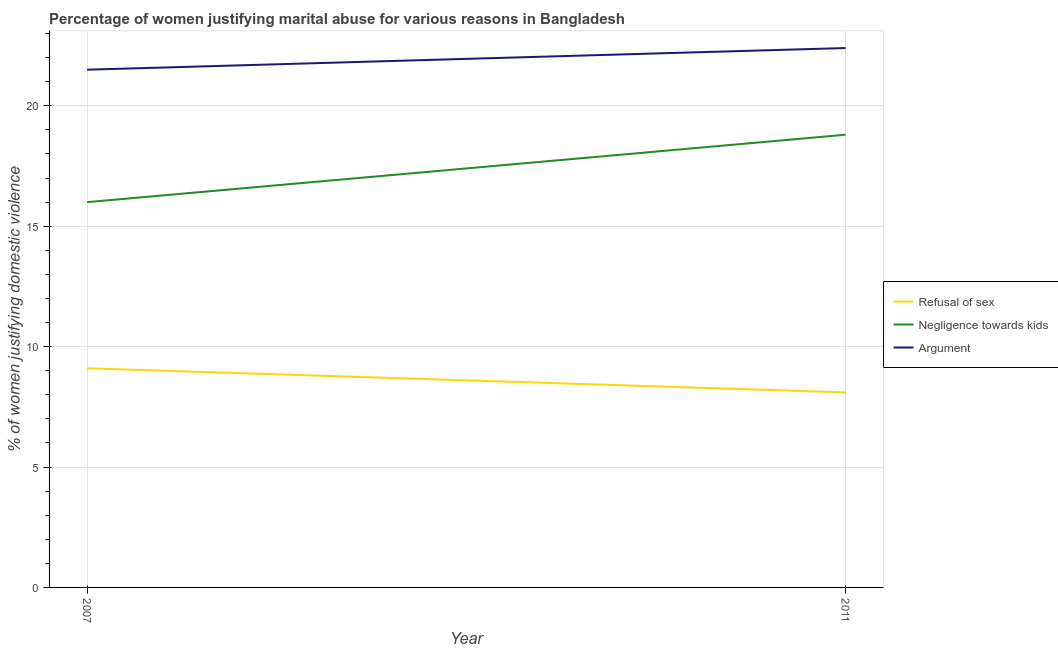Is the number of lines equal to the number of legend labels?
Your response must be concise. Yes. What is the percentage of women justifying domestic violence due to arguments in 2011?
Provide a succinct answer. 22.4. Across all years, what is the maximum percentage of women justifying domestic violence due to refusal of sex?
Provide a short and direct response. 9.1. In which year was the percentage of women justifying domestic violence due to refusal of sex maximum?
Give a very brief answer. 2007. What is the total percentage of women justifying domestic violence due to arguments in the graph?
Your answer should be compact. 43.9. In the year 2011, what is the difference between the percentage of women justifying domestic violence due to refusal of sex and percentage of women justifying domestic violence due to arguments?
Give a very brief answer. -14.3. What is the ratio of the percentage of women justifying domestic violence due to negligence towards kids in 2007 to that in 2011?
Offer a very short reply. 0.85. In how many years, is the percentage of women justifying domestic violence due to refusal of sex greater than the average percentage of women justifying domestic violence due to refusal of sex taken over all years?
Your answer should be compact. 1. Is it the case that in every year, the sum of the percentage of women justifying domestic violence due to refusal of sex and percentage of women justifying domestic violence due to negligence towards kids is greater than the percentage of women justifying domestic violence due to arguments?
Provide a short and direct response. Yes. Is the percentage of women justifying domestic violence due to negligence towards kids strictly greater than the percentage of women justifying domestic violence due to refusal of sex over the years?
Keep it short and to the point. Yes. How many years are there in the graph?
Give a very brief answer. 2. What is the difference between two consecutive major ticks on the Y-axis?
Offer a very short reply. 5. Does the graph contain any zero values?
Keep it short and to the point. No. Where does the legend appear in the graph?
Offer a terse response. Center right. How many legend labels are there?
Your answer should be very brief. 3. What is the title of the graph?
Offer a terse response. Percentage of women justifying marital abuse for various reasons in Bangladesh. What is the label or title of the X-axis?
Provide a short and direct response. Year. What is the label or title of the Y-axis?
Provide a succinct answer. % of women justifying domestic violence. What is the % of women justifying domestic violence in Refusal of sex in 2007?
Keep it short and to the point. 9.1. What is the % of women justifying domestic violence in Negligence towards kids in 2007?
Make the answer very short. 16. What is the % of women justifying domestic violence in Argument in 2007?
Provide a short and direct response. 21.5. What is the % of women justifying domestic violence in Refusal of sex in 2011?
Ensure brevity in your answer.  8.1. What is the % of women justifying domestic violence in Argument in 2011?
Your response must be concise. 22.4. Across all years, what is the maximum % of women justifying domestic violence of Refusal of sex?
Your response must be concise. 9.1. Across all years, what is the maximum % of women justifying domestic violence of Argument?
Give a very brief answer. 22.4. Across all years, what is the minimum % of women justifying domestic violence in Negligence towards kids?
Make the answer very short. 16. Across all years, what is the minimum % of women justifying domestic violence in Argument?
Offer a very short reply. 21.5. What is the total % of women justifying domestic violence in Refusal of sex in the graph?
Your answer should be very brief. 17.2. What is the total % of women justifying domestic violence of Negligence towards kids in the graph?
Make the answer very short. 34.8. What is the total % of women justifying domestic violence of Argument in the graph?
Make the answer very short. 43.9. What is the difference between the % of women justifying domestic violence in Negligence towards kids in 2007 and that in 2011?
Provide a succinct answer. -2.8. What is the difference between the % of women justifying domestic violence of Refusal of sex in 2007 and the % of women justifying domestic violence of Argument in 2011?
Keep it short and to the point. -13.3. What is the difference between the % of women justifying domestic violence of Negligence towards kids in 2007 and the % of women justifying domestic violence of Argument in 2011?
Ensure brevity in your answer.  -6.4. What is the average % of women justifying domestic violence of Refusal of sex per year?
Make the answer very short. 8.6. What is the average % of women justifying domestic violence in Negligence towards kids per year?
Keep it short and to the point. 17.4. What is the average % of women justifying domestic violence in Argument per year?
Make the answer very short. 21.95. In the year 2007, what is the difference between the % of women justifying domestic violence in Refusal of sex and % of women justifying domestic violence in Argument?
Provide a short and direct response. -12.4. In the year 2007, what is the difference between the % of women justifying domestic violence of Negligence towards kids and % of women justifying domestic violence of Argument?
Your response must be concise. -5.5. In the year 2011, what is the difference between the % of women justifying domestic violence in Refusal of sex and % of women justifying domestic violence in Argument?
Give a very brief answer. -14.3. What is the ratio of the % of women justifying domestic violence in Refusal of sex in 2007 to that in 2011?
Your answer should be compact. 1.12. What is the ratio of the % of women justifying domestic violence in Negligence towards kids in 2007 to that in 2011?
Your response must be concise. 0.85. What is the ratio of the % of women justifying domestic violence of Argument in 2007 to that in 2011?
Keep it short and to the point. 0.96. What is the difference between the highest and the second highest % of women justifying domestic violence of Refusal of sex?
Make the answer very short. 1. What is the difference between the highest and the second highest % of women justifying domestic violence of Negligence towards kids?
Your answer should be very brief. 2.8. What is the difference between the highest and the second highest % of women justifying domestic violence of Argument?
Offer a terse response. 0.9. What is the difference between the highest and the lowest % of women justifying domestic violence in Refusal of sex?
Give a very brief answer. 1. What is the difference between the highest and the lowest % of women justifying domestic violence of Negligence towards kids?
Make the answer very short. 2.8. 